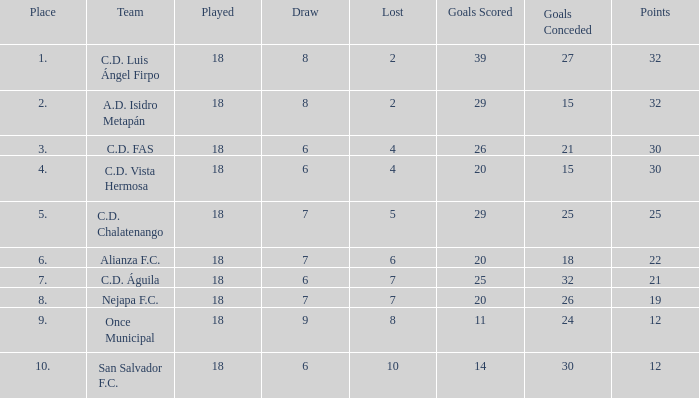Which team with less than 25 goals conceded is in a position better than 3rd place? A.D. Isidro Metapán. 